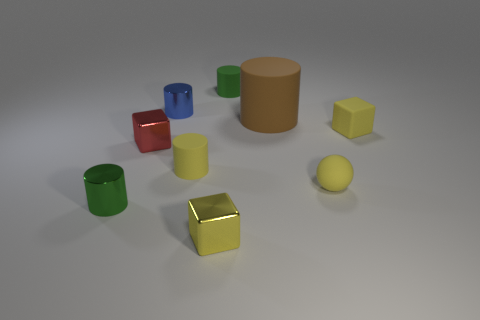Subtract all yellow blocks. How many were subtracted if there are1yellow blocks left? 1 Subtract all tiny yellow cylinders. How many cylinders are left? 4 Subtract all yellow cylinders. How many yellow blocks are left? 2 Subtract all yellow cylinders. How many cylinders are left? 4 Add 1 yellow shiny balls. How many objects exist? 10 Subtract all blue cylinders. Subtract all blue cubes. How many cylinders are left? 4 Subtract all spheres. How many objects are left? 8 Add 6 yellow rubber balls. How many yellow rubber balls are left? 7 Add 3 yellow rubber spheres. How many yellow rubber spheres exist? 4 Subtract 1 yellow cylinders. How many objects are left? 8 